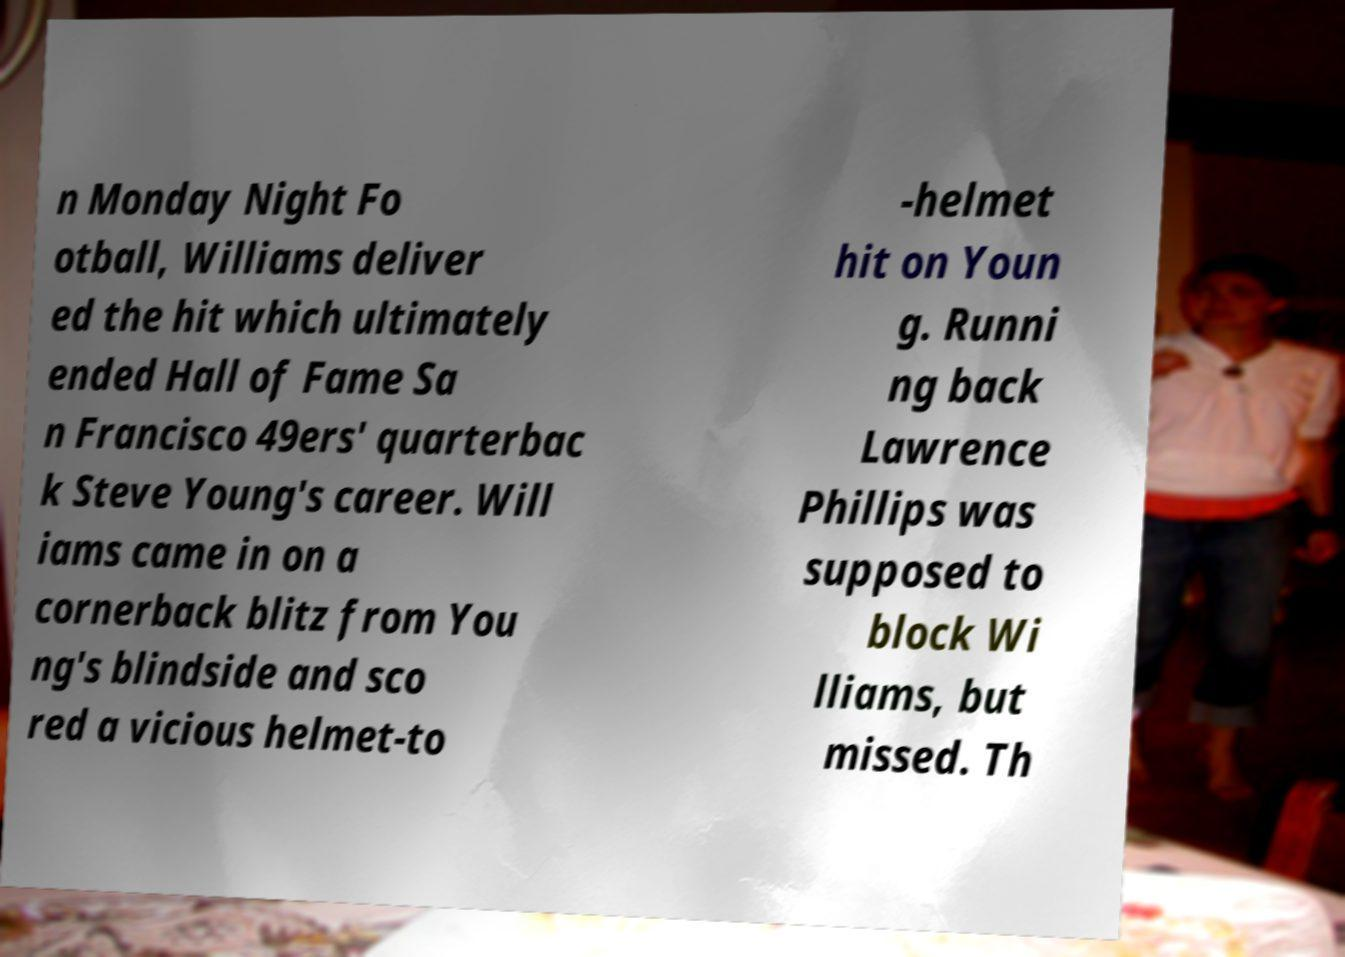Can you read and provide the text displayed in the image?This photo seems to have some interesting text. Can you extract and type it out for me? n Monday Night Fo otball, Williams deliver ed the hit which ultimately ended Hall of Fame Sa n Francisco 49ers' quarterbac k Steve Young's career. Will iams came in on a cornerback blitz from You ng's blindside and sco red a vicious helmet-to -helmet hit on Youn g. Runni ng back Lawrence Phillips was supposed to block Wi lliams, but missed. Th 